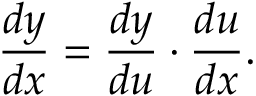<formula> <loc_0><loc_0><loc_500><loc_500>{ \frac { d y } { d x } } = { \frac { d y } { d u } } \cdot { \frac { d u } { d x } } .</formula> 